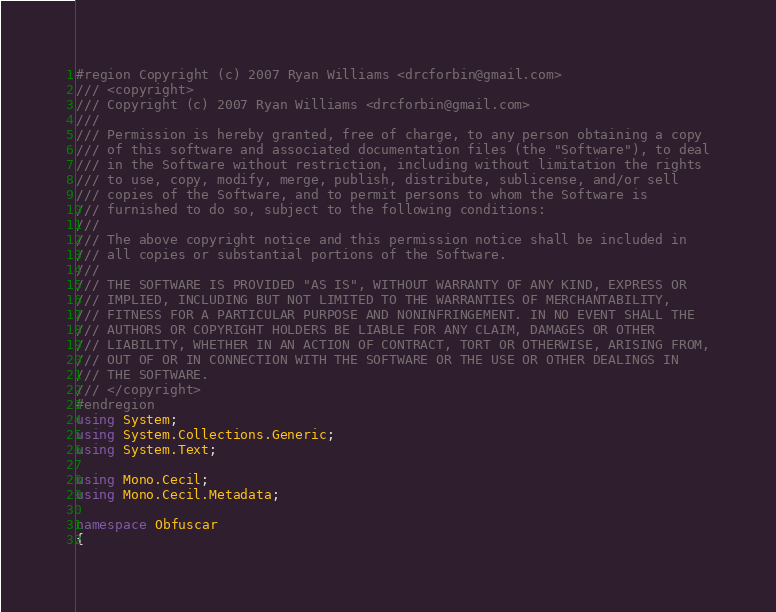Convert code to text. <code><loc_0><loc_0><loc_500><loc_500><_C#_>#region Copyright (c) 2007 Ryan Williams <drcforbin@gmail.com>
/// <copyright>
/// Copyright (c) 2007 Ryan Williams <drcforbin@gmail.com>
/// 
/// Permission is hereby granted, free of charge, to any person obtaining a copy
/// of this software and associated documentation files (the "Software"), to deal
/// in the Software without restriction, including without limitation the rights
/// to use, copy, modify, merge, publish, distribute, sublicense, and/or sell
/// copies of the Software, and to permit persons to whom the Software is
/// furnished to do so, subject to the following conditions:
/// 
/// The above copyright notice and this permission notice shall be included in
/// all copies or substantial portions of the Software.
/// 
/// THE SOFTWARE IS PROVIDED "AS IS", WITHOUT WARRANTY OF ANY KIND, EXPRESS OR
/// IMPLIED, INCLUDING BUT NOT LIMITED TO THE WARRANTIES OF MERCHANTABILITY,
/// FITNESS FOR A PARTICULAR PURPOSE AND NONINFRINGEMENT. IN NO EVENT SHALL THE
/// AUTHORS OR COPYRIGHT HOLDERS BE LIABLE FOR ANY CLAIM, DAMAGES OR OTHER
/// LIABILITY, WHETHER IN AN ACTION OF CONTRACT, TORT OR OTHERWISE, ARISING FROM,
/// OUT OF OR IN CONNECTION WITH THE SOFTWARE OR THE USE OR OTHER DEALINGS IN
/// THE SOFTWARE.
/// </copyright>
#endregion
using System;
using System.Collections.Generic;
using System.Text;

using Mono.Cecil;
using Mono.Cecil.Metadata;

namespace Obfuscar
{</code> 